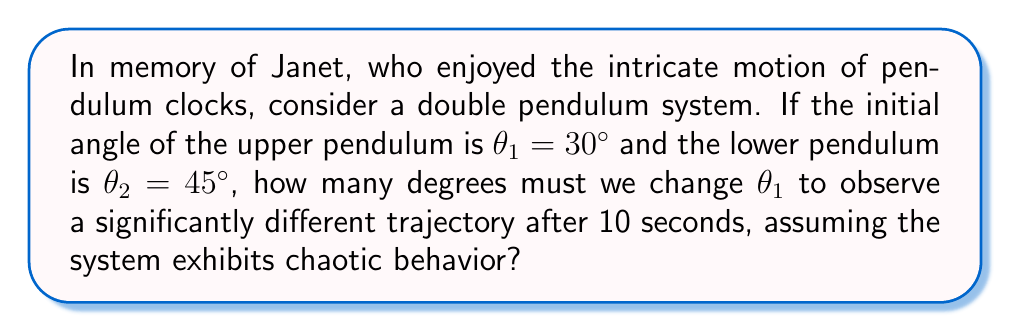Can you solve this math problem? To answer this question, we need to understand the sensitivity to initial conditions in chaotic systems like the double pendulum:

1) The double pendulum is a classic example of a chaotic system, where small changes in initial conditions can lead to drastically different outcomes over time.

2) The Lyapunov exponent ($\lambda$) is a measure of this sensitivity. For chaotic systems, $\lambda > 0$.

3) The divergence of nearby trajectories in phase space is approximately given by:

   $$d(t) \approx d_0 e^{\lambda t}$$

   where $d_0$ is the initial separation and $d(t)$ is the separation at time $t$.

4) For a typical double pendulum, $\lambda \approx 2$ s^(-1).

5) We consider a "significant" difference to be when $d(t) \approx 1$ radian ≈ 57.3°.

6) Substituting into the equation:

   $$57.3° \approx d_0 e^{2 \cdot 10}$$

7) Solving for $d_0$:

   $$d_0 \approx 57.3° \cdot e^{-20} \approx 2.58 \times 10^{-8}°$$

8) This tiny change in the initial angle would result in a significantly different trajectory after 10 seconds.

Therefore, changing $\theta_1$ by just a fraction of a degree (about 0.0000000258°) would be sufficient to observe a significantly different trajectory after 10 seconds.
Answer: $2.58 \times 10^{-8}°$ 